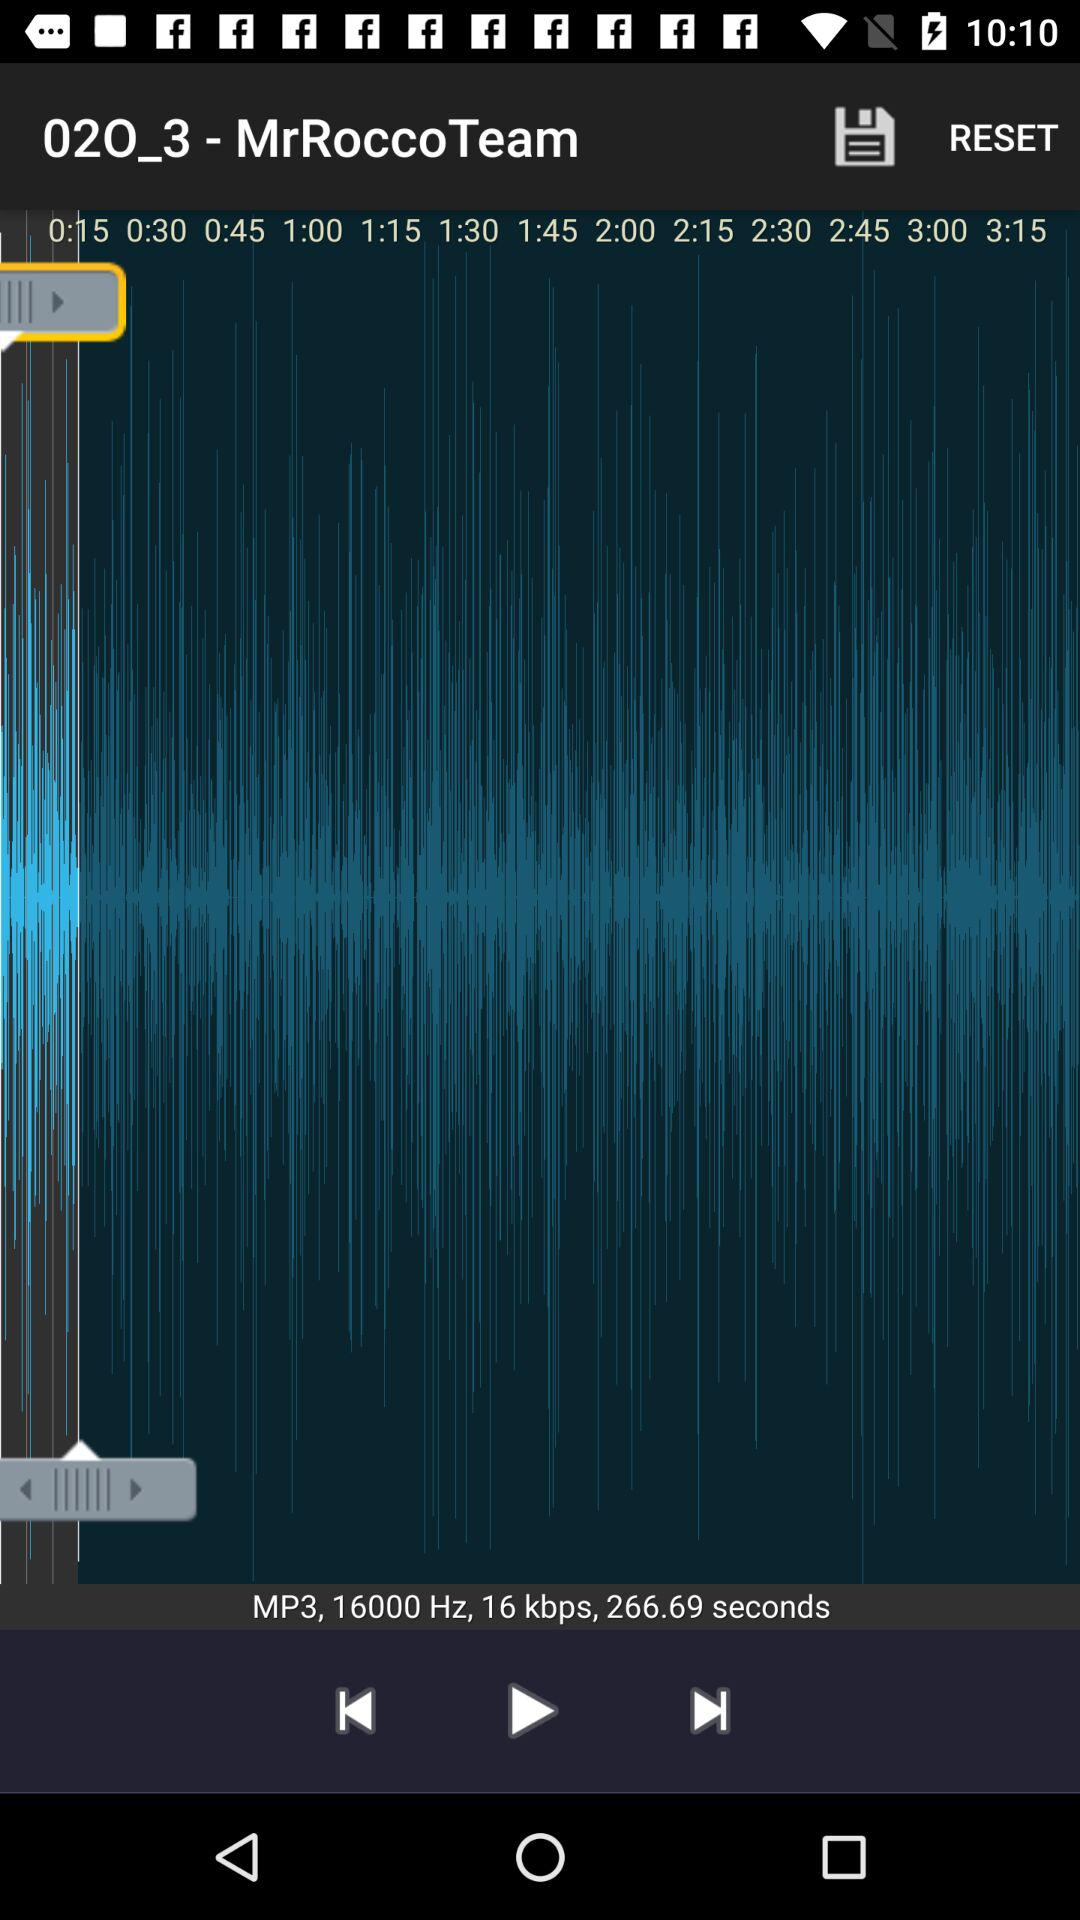What is the frequency of the audio? The frequency is 16000 Hz. 